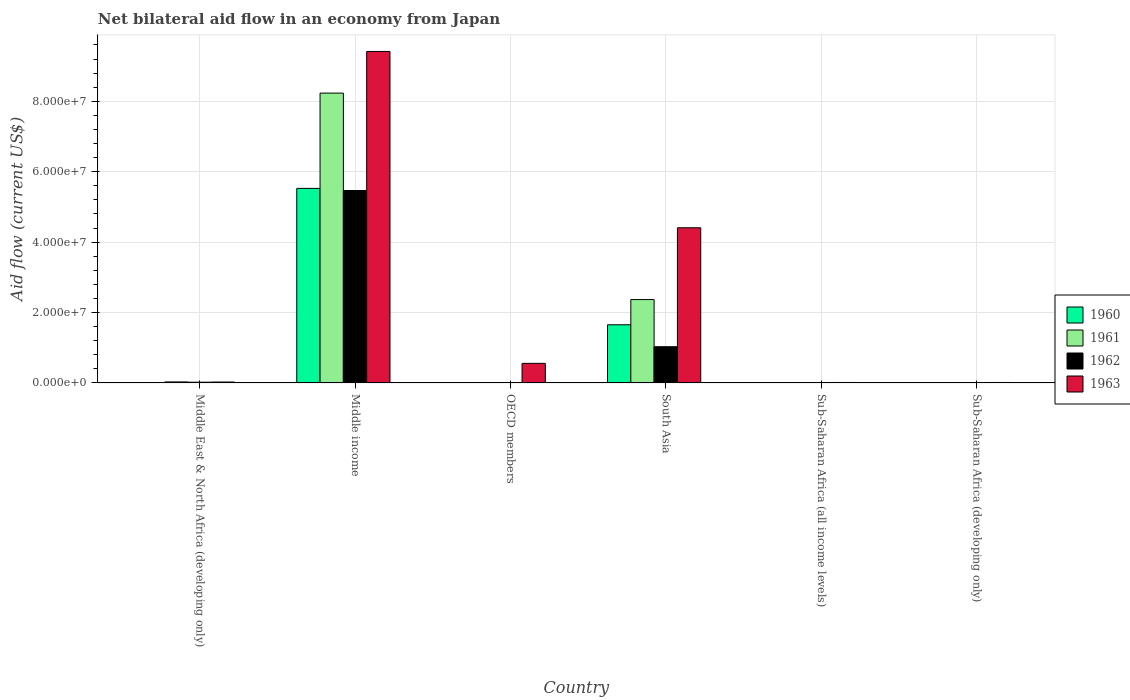How many different coloured bars are there?
Offer a terse response. 4. How many groups of bars are there?
Make the answer very short. 6. How many bars are there on the 5th tick from the left?
Provide a short and direct response. 4. How many bars are there on the 4th tick from the right?
Provide a succinct answer. 4. What is the label of the 1st group of bars from the left?
Provide a short and direct response. Middle East & North Africa (developing only). In how many cases, is the number of bars for a given country not equal to the number of legend labels?
Provide a succinct answer. 0. What is the net bilateral aid flow in 1960 in Middle East & North Africa (developing only)?
Provide a succinct answer. 9.00e+04. Across all countries, what is the maximum net bilateral aid flow in 1960?
Make the answer very short. 5.53e+07. Across all countries, what is the minimum net bilateral aid flow in 1961?
Your response must be concise. 3.00e+04. In which country was the net bilateral aid flow in 1963 maximum?
Provide a succinct answer. Middle income. In which country was the net bilateral aid flow in 1960 minimum?
Offer a very short reply. Sub-Saharan Africa (all income levels). What is the total net bilateral aid flow in 1962 in the graph?
Your response must be concise. 6.55e+07. What is the difference between the net bilateral aid flow in 1960 in Middle East & North Africa (developing only) and that in South Asia?
Ensure brevity in your answer.  -1.64e+07. What is the difference between the net bilateral aid flow in 1963 in South Asia and the net bilateral aid flow in 1960 in OECD members?
Offer a very short reply. 4.40e+07. What is the average net bilateral aid flow in 1961 per country?
Provide a short and direct response. 1.77e+07. In how many countries, is the net bilateral aid flow in 1963 greater than 64000000 US$?
Make the answer very short. 1. What is the ratio of the net bilateral aid flow in 1963 in OECD members to that in South Asia?
Keep it short and to the point. 0.13. Is the net bilateral aid flow in 1961 in Middle East & North Africa (developing only) less than that in OECD members?
Offer a very short reply. No. What is the difference between the highest and the second highest net bilateral aid flow in 1963?
Provide a succinct answer. 5.01e+07. What is the difference between the highest and the lowest net bilateral aid flow in 1960?
Ensure brevity in your answer.  5.52e+07. Is the sum of the net bilateral aid flow in 1961 in Middle income and Sub-Saharan Africa (developing only) greater than the maximum net bilateral aid flow in 1962 across all countries?
Provide a succinct answer. Yes. Is it the case that in every country, the sum of the net bilateral aid flow in 1960 and net bilateral aid flow in 1962 is greater than the sum of net bilateral aid flow in 1963 and net bilateral aid flow in 1961?
Provide a succinct answer. No. Is it the case that in every country, the sum of the net bilateral aid flow in 1961 and net bilateral aid flow in 1963 is greater than the net bilateral aid flow in 1962?
Your answer should be compact. Yes. Are all the bars in the graph horizontal?
Make the answer very short. No. How many countries are there in the graph?
Give a very brief answer. 6. Are the values on the major ticks of Y-axis written in scientific E-notation?
Your response must be concise. Yes. Where does the legend appear in the graph?
Your answer should be compact. Center right. How many legend labels are there?
Your answer should be very brief. 4. What is the title of the graph?
Provide a short and direct response. Net bilateral aid flow in an economy from Japan. What is the Aid flow (current US$) of 1960 in Middle East & North Africa (developing only)?
Your answer should be compact. 9.00e+04. What is the Aid flow (current US$) of 1961 in Middle East & North Africa (developing only)?
Make the answer very short. 2.90e+05. What is the Aid flow (current US$) in 1962 in Middle East & North Africa (developing only)?
Offer a terse response. 2.10e+05. What is the Aid flow (current US$) of 1960 in Middle income?
Provide a short and direct response. 5.53e+07. What is the Aid flow (current US$) in 1961 in Middle income?
Offer a very short reply. 8.23e+07. What is the Aid flow (current US$) of 1962 in Middle income?
Give a very brief answer. 5.47e+07. What is the Aid flow (current US$) in 1963 in Middle income?
Offer a very short reply. 9.42e+07. What is the Aid flow (current US$) in 1960 in OECD members?
Your answer should be very brief. 3.00e+04. What is the Aid flow (current US$) in 1961 in OECD members?
Offer a terse response. 5.00e+04. What is the Aid flow (current US$) in 1963 in OECD members?
Provide a short and direct response. 5.56e+06. What is the Aid flow (current US$) of 1960 in South Asia?
Make the answer very short. 1.65e+07. What is the Aid flow (current US$) in 1961 in South Asia?
Provide a short and direct response. 2.37e+07. What is the Aid flow (current US$) of 1962 in South Asia?
Keep it short and to the point. 1.03e+07. What is the Aid flow (current US$) in 1963 in South Asia?
Provide a succinct answer. 4.41e+07. What is the Aid flow (current US$) in 1961 in Sub-Saharan Africa (all income levels)?
Offer a terse response. 3.00e+04. What is the Aid flow (current US$) in 1962 in Sub-Saharan Africa (all income levels)?
Keep it short and to the point. 1.10e+05. What is the Aid flow (current US$) of 1963 in Sub-Saharan Africa (all income levels)?
Your answer should be compact. 1.30e+05. Across all countries, what is the maximum Aid flow (current US$) of 1960?
Give a very brief answer. 5.53e+07. Across all countries, what is the maximum Aid flow (current US$) in 1961?
Make the answer very short. 8.23e+07. Across all countries, what is the maximum Aid flow (current US$) in 1962?
Give a very brief answer. 5.47e+07. Across all countries, what is the maximum Aid flow (current US$) of 1963?
Offer a very short reply. 9.42e+07. Across all countries, what is the minimum Aid flow (current US$) in 1962?
Make the answer very short. 9.00e+04. Across all countries, what is the minimum Aid flow (current US$) of 1963?
Offer a very short reply. 1.30e+05. What is the total Aid flow (current US$) in 1960 in the graph?
Keep it short and to the point. 7.19e+07. What is the total Aid flow (current US$) of 1961 in the graph?
Ensure brevity in your answer.  1.06e+08. What is the total Aid flow (current US$) of 1962 in the graph?
Ensure brevity in your answer.  6.55e+07. What is the total Aid flow (current US$) of 1963 in the graph?
Ensure brevity in your answer.  1.44e+08. What is the difference between the Aid flow (current US$) in 1960 in Middle East & North Africa (developing only) and that in Middle income?
Give a very brief answer. -5.52e+07. What is the difference between the Aid flow (current US$) in 1961 in Middle East & North Africa (developing only) and that in Middle income?
Keep it short and to the point. -8.20e+07. What is the difference between the Aid flow (current US$) in 1962 in Middle East & North Africa (developing only) and that in Middle income?
Give a very brief answer. -5.44e+07. What is the difference between the Aid flow (current US$) in 1963 in Middle East & North Africa (developing only) and that in Middle income?
Offer a terse response. -9.39e+07. What is the difference between the Aid flow (current US$) of 1962 in Middle East & North Africa (developing only) and that in OECD members?
Keep it short and to the point. 1.20e+05. What is the difference between the Aid flow (current US$) of 1963 in Middle East & North Africa (developing only) and that in OECD members?
Provide a short and direct response. -5.30e+06. What is the difference between the Aid flow (current US$) of 1960 in Middle East & North Africa (developing only) and that in South Asia?
Your answer should be very brief. -1.64e+07. What is the difference between the Aid flow (current US$) of 1961 in Middle East & North Africa (developing only) and that in South Asia?
Your answer should be very brief. -2.34e+07. What is the difference between the Aid flow (current US$) in 1962 in Middle East & North Africa (developing only) and that in South Asia?
Make the answer very short. -1.01e+07. What is the difference between the Aid flow (current US$) of 1963 in Middle East & North Africa (developing only) and that in South Asia?
Keep it short and to the point. -4.38e+07. What is the difference between the Aid flow (current US$) of 1960 in Middle income and that in OECD members?
Give a very brief answer. 5.52e+07. What is the difference between the Aid flow (current US$) in 1961 in Middle income and that in OECD members?
Provide a succinct answer. 8.23e+07. What is the difference between the Aid flow (current US$) of 1962 in Middle income and that in OECD members?
Ensure brevity in your answer.  5.46e+07. What is the difference between the Aid flow (current US$) of 1963 in Middle income and that in OECD members?
Your answer should be compact. 8.86e+07. What is the difference between the Aid flow (current US$) of 1960 in Middle income and that in South Asia?
Offer a very short reply. 3.87e+07. What is the difference between the Aid flow (current US$) of 1961 in Middle income and that in South Asia?
Provide a short and direct response. 5.86e+07. What is the difference between the Aid flow (current US$) in 1962 in Middle income and that in South Asia?
Your answer should be very brief. 4.44e+07. What is the difference between the Aid flow (current US$) of 1963 in Middle income and that in South Asia?
Offer a very short reply. 5.01e+07. What is the difference between the Aid flow (current US$) of 1960 in Middle income and that in Sub-Saharan Africa (all income levels)?
Offer a terse response. 5.52e+07. What is the difference between the Aid flow (current US$) in 1961 in Middle income and that in Sub-Saharan Africa (all income levels)?
Keep it short and to the point. 8.23e+07. What is the difference between the Aid flow (current US$) in 1962 in Middle income and that in Sub-Saharan Africa (all income levels)?
Provide a succinct answer. 5.46e+07. What is the difference between the Aid flow (current US$) of 1963 in Middle income and that in Sub-Saharan Africa (all income levels)?
Offer a terse response. 9.40e+07. What is the difference between the Aid flow (current US$) of 1960 in Middle income and that in Sub-Saharan Africa (developing only)?
Give a very brief answer. 5.52e+07. What is the difference between the Aid flow (current US$) in 1961 in Middle income and that in Sub-Saharan Africa (developing only)?
Your answer should be compact. 8.23e+07. What is the difference between the Aid flow (current US$) of 1962 in Middle income and that in Sub-Saharan Africa (developing only)?
Offer a terse response. 5.46e+07. What is the difference between the Aid flow (current US$) in 1963 in Middle income and that in Sub-Saharan Africa (developing only)?
Give a very brief answer. 9.40e+07. What is the difference between the Aid flow (current US$) in 1960 in OECD members and that in South Asia?
Your answer should be compact. -1.65e+07. What is the difference between the Aid flow (current US$) in 1961 in OECD members and that in South Asia?
Your response must be concise. -2.36e+07. What is the difference between the Aid flow (current US$) in 1962 in OECD members and that in South Asia?
Your response must be concise. -1.02e+07. What is the difference between the Aid flow (current US$) in 1963 in OECD members and that in South Asia?
Offer a terse response. -3.85e+07. What is the difference between the Aid flow (current US$) in 1960 in OECD members and that in Sub-Saharan Africa (all income levels)?
Make the answer very short. 10000. What is the difference between the Aid flow (current US$) of 1961 in OECD members and that in Sub-Saharan Africa (all income levels)?
Your answer should be compact. 2.00e+04. What is the difference between the Aid flow (current US$) in 1962 in OECD members and that in Sub-Saharan Africa (all income levels)?
Provide a succinct answer. -2.00e+04. What is the difference between the Aid flow (current US$) in 1963 in OECD members and that in Sub-Saharan Africa (all income levels)?
Provide a succinct answer. 5.43e+06. What is the difference between the Aid flow (current US$) in 1962 in OECD members and that in Sub-Saharan Africa (developing only)?
Make the answer very short. -2.00e+04. What is the difference between the Aid flow (current US$) of 1963 in OECD members and that in Sub-Saharan Africa (developing only)?
Make the answer very short. 5.43e+06. What is the difference between the Aid flow (current US$) of 1960 in South Asia and that in Sub-Saharan Africa (all income levels)?
Provide a short and direct response. 1.65e+07. What is the difference between the Aid flow (current US$) of 1961 in South Asia and that in Sub-Saharan Africa (all income levels)?
Give a very brief answer. 2.36e+07. What is the difference between the Aid flow (current US$) in 1962 in South Asia and that in Sub-Saharan Africa (all income levels)?
Keep it short and to the point. 1.02e+07. What is the difference between the Aid flow (current US$) of 1963 in South Asia and that in Sub-Saharan Africa (all income levels)?
Provide a succinct answer. 4.39e+07. What is the difference between the Aid flow (current US$) in 1960 in South Asia and that in Sub-Saharan Africa (developing only)?
Offer a terse response. 1.65e+07. What is the difference between the Aid flow (current US$) in 1961 in South Asia and that in Sub-Saharan Africa (developing only)?
Give a very brief answer. 2.36e+07. What is the difference between the Aid flow (current US$) of 1962 in South Asia and that in Sub-Saharan Africa (developing only)?
Offer a very short reply. 1.02e+07. What is the difference between the Aid flow (current US$) of 1963 in South Asia and that in Sub-Saharan Africa (developing only)?
Your answer should be compact. 4.39e+07. What is the difference between the Aid flow (current US$) of 1961 in Sub-Saharan Africa (all income levels) and that in Sub-Saharan Africa (developing only)?
Your answer should be compact. 0. What is the difference between the Aid flow (current US$) of 1963 in Sub-Saharan Africa (all income levels) and that in Sub-Saharan Africa (developing only)?
Provide a succinct answer. 0. What is the difference between the Aid flow (current US$) in 1960 in Middle East & North Africa (developing only) and the Aid flow (current US$) in 1961 in Middle income?
Make the answer very short. -8.22e+07. What is the difference between the Aid flow (current US$) in 1960 in Middle East & North Africa (developing only) and the Aid flow (current US$) in 1962 in Middle income?
Offer a very short reply. -5.46e+07. What is the difference between the Aid flow (current US$) of 1960 in Middle East & North Africa (developing only) and the Aid flow (current US$) of 1963 in Middle income?
Offer a terse response. -9.41e+07. What is the difference between the Aid flow (current US$) in 1961 in Middle East & North Africa (developing only) and the Aid flow (current US$) in 1962 in Middle income?
Keep it short and to the point. -5.44e+07. What is the difference between the Aid flow (current US$) in 1961 in Middle East & North Africa (developing only) and the Aid flow (current US$) in 1963 in Middle income?
Offer a terse response. -9.39e+07. What is the difference between the Aid flow (current US$) in 1962 in Middle East & North Africa (developing only) and the Aid flow (current US$) in 1963 in Middle income?
Provide a short and direct response. -9.39e+07. What is the difference between the Aid flow (current US$) of 1960 in Middle East & North Africa (developing only) and the Aid flow (current US$) of 1962 in OECD members?
Offer a terse response. 0. What is the difference between the Aid flow (current US$) of 1960 in Middle East & North Africa (developing only) and the Aid flow (current US$) of 1963 in OECD members?
Make the answer very short. -5.47e+06. What is the difference between the Aid flow (current US$) of 1961 in Middle East & North Africa (developing only) and the Aid flow (current US$) of 1963 in OECD members?
Provide a short and direct response. -5.27e+06. What is the difference between the Aid flow (current US$) of 1962 in Middle East & North Africa (developing only) and the Aid flow (current US$) of 1963 in OECD members?
Give a very brief answer. -5.35e+06. What is the difference between the Aid flow (current US$) of 1960 in Middle East & North Africa (developing only) and the Aid flow (current US$) of 1961 in South Asia?
Your response must be concise. -2.36e+07. What is the difference between the Aid flow (current US$) of 1960 in Middle East & North Africa (developing only) and the Aid flow (current US$) of 1962 in South Asia?
Offer a very short reply. -1.02e+07. What is the difference between the Aid flow (current US$) in 1960 in Middle East & North Africa (developing only) and the Aid flow (current US$) in 1963 in South Asia?
Offer a very short reply. -4.40e+07. What is the difference between the Aid flow (current US$) of 1961 in Middle East & North Africa (developing only) and the Aid flow (current US$) of 1962 in South Asia?
Provide a succinct answer. -1.00e+07. What is the difference between the Aid flow (current US$) of 1961 in Middle East & North Africa (developing only) and the Aid flow (current US$) of 1963 in South Asia?
Make the answer very short. -4.38e+07. What is the difference between the Aid flow (current US$) in 1962 in Middle East & North Africa (developing only) and the Aid flow (current US$) in 1963 in South Asia?
Ensure brevity in your answer.  -4.39e+07. What is the difference between the Aid flow (current US$) of 1960 in Middle East & North Africa (developing only) and the Aid flow (current US$) of 1961 in Sub-Saharan Africa (all income levels)?
Offer a very short reply. 6.00e+04. What is the difference between the Aid flow (current US$) in 1960 in Middle East & North Africa (developing only) and the Aid flow (current US$) in 1962 in Sub-Saharan Africa (all income levels)?
Offer a very short reply. -2.00e+04. What is the difference between the Aid flow (current US$) in 1960 in Middle East & North Africa (developing only) and the Aid flow (current US$) in 1963 in Sub-Saharan Africa (all income levels)?
Your answer should be compact. -4.00e+04. What is the difference between the Aid flow (current US$) of 1960 in Middle East & North Africa (developing only) and the Aid flow (current US$) of 1961 in Sub-Saharan Africa (developing only)?
Provide a short and direct response. 6.00e+04. What is the difference between the Aid flow (current US$) in 1960 in Middle East & North Africa (developing only) and the Aid flow (current US$) in 1962 in Sub-Saharan Africa (developing only)?
Provide a succinct answer. -2.00e+04. What is the difference between the Aid flow (current US$) in 1960 in Middle income and the Aid flow (current US$) in 1961 in OECD members?
Give a very brief answer. 5.52e+07. What is the difference between the Aid flow (current US$) of 1960 in Middle income and the Aid flow (current US$) of 1962 in OECD members?
Offer a very short reply. 5.52e+07. What is the difference between the Aid flow (current US$) in 1960 in Middle income and the Aid flow (current US$) in 1963 in OECD members?
Your answer should be very brief. 4.97e+07. What is the difference between the Aid flow (current US$) of 1961 in Middle income and the Aid flow (current US$) of 1962 in OECD members?
Make the answer very short. 8.22e+07. What is the difference between the Aid flow (current US$) in 1961 in Middle income and the Aid flow (current US$) in 1963 in OECD members?
Make the answer very short. 7.68e+07. What is the difference between the Aid flow (current US$) in 1962 in Middle income and the Aid flow (current US$) in 1963 in OECD members?
Your response must be concise. 4.91e+07. What is the difference between the Aid flow (current US$) of 1960 in Middle income and the Aid flow (current US$) of 1961 in South Asia?
Your answer should be compact. 3.16e+07. What is the difference between the Aid flow (current US$) in 1960 in Middle income and the Aid flow (current US$) in 1962 in South Asia?
Provide a short and direct response. 4.50e+07. What is the difference between the Aid flow (current US$) in 1960 in Middle income and the Aid flow (current US$) in 1963 in South Asia?
Provide a succinct answer. 1.12e+07. What is the difference between the Aid flow (current US$) of 1961 in Middle income and the Aid flow (current US$) of 1962 in South Asia?
Make the answer very short. 7.20e+07. What is the difference between the Aid flow (current US$) in 1961 in Middle income and the Aid flow (current US$) in 1963 in South Asia?
Offer a terse response. 3.82e+07. What is the difference between the Aid flow (current US$) of 1962 in Middle income and the Aid flow (current US$) of 1963 in South Asia?
Offer a very short reply. 1.06e+07. What is the difference between the Aid flow (current US$) in 1960 in Middle income and the Aid flow (current US$) in 1961 in Sub-Saharan Africa (all income levels)?
Offer a very short reply. 5.52e+07. What is the difference between the Aid flow (current US$) in 1960 in Middle income and the Aid flow (current US$) in 1962 in Sub-Saharan Africa (all income levels)?
Provide a short and direct response. 5.52e+07. What is the difference between the Aid flow (current US$) in 1960 in Middle income and the Aid flow (current US$) in 1963 in Sub-Saharan Africa (all income levels)?
Ensure brevity in your answer.  5.51e+07. What is the difference between the Aid flow (current US$) in 1961 in Middle income and the Aid flow (current US$) in 1962 in Sub-Saharan Africa (all income levels)?
Keep it short and to the point. 8.22e+07. What is the difference between the Aid flow (current US$) in 1961 in Middle income and the Aid flow (current US$) in 1963 in Sub-Saharan Africa (all income levels)?
Your answer should be very brief. 8.22e+07. What is the difference between the Aid flow (current US$) in 1962 in Middle income and the Aid flow (current US$) in 1963 in Sub-Saharan Africa (all income levels)?
Your answer should be compact. 5.45e+07. What is the difference between the Aid flow (current US$) of 1960 in Middle income and the Aid flow (current US$) of 1961 in Sub-Saharan Africa (developing only)?
Your response must be concise. 5.52e+07. What is the difference between the Aid flow (current US$) in 1960 in Middle income and the Aid flow (current US$) in 1962 in Sub-Saharan Africa (developing only)?
Ensure brevity in your answer.  5.52e+07. What is the difference between the Aid flow (current US$) of 1960 in Middle income and the Aid flow (current US$) of 1963 in Sub-Saharan Africa (developing only)?
Your answer should be very brief. 5.51e+07. What is the difference between the Aid flow (current US$) of 1961 in Middle income and the Aid flow (current US$) of 1962 in Sub-Saharan Africa (developing only)?
Provide a succinct answer. 8.22e+07. What is the difference between the Aid flow (current US$) of 1961 in Middle income and the Aid flow (current US$) of 1963 in Sub-Saharan Africa (developing only)?
Your response must be concise. 8.22e+07. What is the difference between the Aid flow (current US$) in 1962 in Middle income and the Aid flow (current US$) in 1963 in Sub-Saharan Africa (developing only)?
Ensure brevity in your answer.  5.45e+07. What is the difference between the Aid flow (current US$) of 1960 in OECD members and the Aid flow (current US$) of 1961 in South Asia?
Keep it short and to the point. -2.36e+07. What is the difference between the Aid flow (current US$) in 1960 in OECD members and the Aid flow (current US$) in 1962 in South Asia?
Your answer should be compact. -1.03e+07. What is the difference between the Aid flow (current US$) in 1960 in OECD members and the Aid flow (current US$) in 1963 in South Asia?
Make the answer very short. -4.40e+07. What is the difference between the Aid flow (current US$) in 1961 in OECD members and the Aid flow (current US$) in 1962 in South Asia?
Ensure brevity in your answer.  -1.02e+07. What is the difference between the Aid flow (current US$) of 1961 in OECD members and the Aid flow (current US$) of 1963 in South Asia?
Ensure brevity in your answer.  -4.40e+07. What is the difference between the Aid flow (current US$) in 1962 in OECD members and the Aid flow (current US$) in 1963 in South Asia?
Keep it short and to the point. -4.40e+07. What is the difference between the Aid flow (current US$) in 1960 in OECD members and the Aid flow (current US$) in 1962 in Sub-Saharan Africa (all income levels)?
Ensure brevity in your answer.  -8.00e+04. What is the difference between the Aid flow (current US$) in 1961 in OECD members and the Aid flow (current US$) in 1962 in Sub-Saharan Africa (all income levels)?
Ensure brevity in your answer.  -6.00e+04. What is the difference between the Aid flow (current US$) in 1962 in OECD members and the Aid flow (current US$) in 1963 in Sub-Saharan Africa (all income levels)?
Provide a succinct answer. -4.00e+04. What is the difference between the Aid flow (current US$) of 1960 in OECD members and the Aid flow (current US$) of 1961 in Sub-Saharan Africa (developing only)?
Ensure brevity in your answer.  0. What is the difference between the Aid flow (current US$) in 1961 in OECD members and the Aid flow (current US$) in 1963 in Sub-Saharan Africa (developing only)?
Your response must be concise. -8.00e+04. What is the difference between the Aid flow (current US$) of 1962 in OECD members and the Aid flow (current US$) of 1963 in Sub-Saharan Africa (developing only)?
Offer a terse response. -4.00e+04. What is the difference between the Aid flow (current US$) of 1960 in South Asia and the Aid flow (current US$) of 1961 in Sub-Saharan Africa (all income levels)?
Keep it short and to the point. 1.65e+07. What is the difference between the Aid flow (current US$) in 1960 in South Asia and the Aid flow (current US$) in 1962 in Sub-Saharan Africa (all income levels)?
Make the answer very short. 1.64e+07. What is the difference between the Aid flow (current US$) of 1960 in South Asia and the Aid flow (current US$) of 1963 in Sub-Saharan Africa (all income levels)?
Ensure brevity in your answer.  1.64e+07. What is the difference between the Aid flow (current US$) of 1961 in South Asia and the Aid flow (current US$) of 1962 in Sub-Saharan Africa (all income levels)?
Your answer should be compact. 2.36e+07. What is the difference between the Aid flow (current US$) of 1961 in South Asia and the Aid flow (current US$) of 1963 in Sub-Saharan Africa (all income levels)?
Provide a short and direct response. 2.36e+07. What is the difference between the Aid flow (current US$) of 1962 in South Asia and the Aid flow (current US$) of 1963 in Sub-Saharan Africa (all income levels)?
Offer a very short reply. 1.02e+07. What is the difference between the Aid flow (current US$) in 1960 in South Asia and the Aid flow (current US$) in 1961 in Sub-Saharan Africa (developing only)?
Offer a terse response. 1.65e+07. What is the difference between the Aid flow (current US$) of 1960 in South Asia and the Aid flow (current US$) of 1962 in Sub-Saharan Africa (developing only)?
Make the answer very short. 1.64e+07. What is the difference between the Aid flow (current US$) of 1960 in South Asia and the Aid flow (current US$) of 1963 in Sub-Saharan Africa (developing only)?
Offer a very short reply. 1.64e+07. What is the difference between the Aid flow (current US$) in 1961 in South Asia and the Aid flow (current US$) in 1962 in Sub-Saharan Africa (developing only)?
Your response must be concise. 2.36e+07. What is the difference between the Aid flow (current US$) in 1961 in South Asia and the Aid flow (current US$) in 1963 in Sub-Saharan Africa (developing only)?
Provide a succinct answer. 2.36e+07. What is the difference between the Aid flow (current US$) of 1962 in South Asia and the Aid flow (current US$) of 1963 in Sub-Saharan Africa (developing only)?
Your answer should be very brief. 1.02e+07. What is the difference between the Aid flow (current US$) in 1960 in Sub-Saharan Africa (all income levels) and the Aid flow (current US$) in 1962 in Sub-Saharan Africa (developing only)?
Ensure brevity in your answer.  -9.00e+04. What is the difference between the Aid flow (current US$) in 1960 in Sub-Saharan Africa (all income levels) and the Aid flow (current US$) in 1963 in Sub-Saharan Africa (developing only)?
Ensure brevity in your answer.  -1.10e+05. What is the difference between the Aid flow (current US$) of 1962 in Sub-Saharan Africa (all income levels) and the Aid flow (current US$) of 1963 in Sub-Saharan Africa (developing only)?
Your answer should be compact. -2.00e+04. What is the average Aid flow (current US$) of 1960 per country?
Ensure brevity in your answer.  1.20e+07. What is the average Aid flow (current US$) of 1961 per country?
Make the answer very short. 1.77e+07. What is the average Aid flow (current US$) in 1962 per country?
Offer a very short reply. 1.09e+07. What is the average Aid flow (current US$) of 1963 per country?
Offer a terse response. 2.40e+07. What is the difference between the Aid flow (current US$) of 1961 and Aid flow (current US$) of 1963 in Middle East & North Africa (developing only)?
Ensure brevity in your answer.  3.00e+04. What is the difference between the Aid flow (current US$) in 1960 and Aid flow (current US$) in 1961 in Middle income?
Your answer should be very brief. -2.71e+07. What is the difference between the Aid flow (current US$) in 1960 and Aid flow (current US$) in 1962 in Middle income?
Your answer should be very brief. 6.00e+05. What is the difference between the Aid flow (current US$) in 1960 and Aid flow (current US$) in 1963 in Middle income?
Offer a terse response. -3.89e+07. What is the difference between the Aid flow (current US$) in 1961 and Aid flow (current US$) in 1962 in Middle income?
Your answer should be very brief. 2.77e+07. What is the difference between the Aid flow (current US$) of 1961 and Aid flow (current US$) of 1963 in Middle income?
Make the answer very short. -1.18e+07. What is the difference between the Aid flow (current US$) in 1962 and Aid flow (current US$) in 1963 in Middle income?
Provide a short and direct response. -3.95e+07. What is the difference between the Aid flow (current US$) in 1960 and Aid flow (current US$) in 1961 in OECD members?
Provide a succinct answer. -2.00e+04. What is the difference between the Aid flow (current US$) in 1960 and Aid flow (current US$) in 1962 in OECD members?
Your answer should be compact. -6.00e+04. What is the difference between the Aid flow (current US$) in 1960 and Aid flow (current US$) in 1963 in OECD members?
Offer a terse response. -5.53e+06. What is the difference between the Aid flow (current US$) of 1961 and Aid flow (current US$) of 1963 in OECD members?
Provide a succinct answer. -5.51e+06. What is the difference between the Aid flow (current US$) in 1962 and Aid flow (current US$) in 1963 in OECD members?
Offer a very short reply. -5.47e+06. What is the difference between the Aid flow (current US$) of 1960 and Aid flow (current US$) of 1961 in South Asia?
Provide a short and direct response. -7.16e+06. What is the difference between the Aid flow (current US$) in 1960 and Aid flow (current US$) in 1962 in South Asia?
Provide a succinct answer. 6.23e+06. What is the difference between the Aid flow (current US$) of 1960 and Aid flow (current US$) of 1963 in South Asia?
Keep it short and to the point. -2.76e+07. What is the difference between the Aid flow (current US$) of 1961 and Aid flow (current US$) of 1962 in South Asia?
Offer a terse response. 1.34e+07. What is the difference between the Aid flow (current US$) of 1961 and Aid flow (current US$) of 1963 in South Asia?
Your answer should be very brief. -2.04e+07. What is the difference between the Aid flow (current US$) in 1962 and Aid flow (current US$) in 1963 in South Asia?
Your answer should be very brief. -3.38e+07. What is the difference between the Aid flow (current US$) in 1960 and Aid flow (current US$) in 1962 in Sub-Saharan Africa (all income levels)?
Your answer should be very brief. -9.00e+04. What is the difference between the Aid flow (current US$) in 1960 and Aid flow (current US$) in 1963 in Sub-Saharan Africa (all income levels)?
Offer a terse response. -1.10e+05. What is the difference between the Aid flow (current US$) in 1961 and Aid flow (current US$) in 1962 in Sub-Saharan Africa (all income levels)?
Make the answer very short. -8.00e+04. What is the difference between the Aid flow (current US$) of 1961 and Aid flow (current US$) of 1963 in Sub-Saharan Africa (all income levels)?
Your response must be concise. -1.00e+05. What is the difference between the Aid flow (current US$) in 1960 and Aid flow (current US$) in 1963 in Sub-Saharan Africa (developing only)?
Keep it short and to the point. -1.10e+05. What is the difference between the Aid flow (current US$) in 1961 and Aid flow (current US$) in 1962 in Sub-Saharan Africa (developing only)?
Provide a succinct answer. -8.00e+04. What is the difference between the Aid flow (current US$) in 1962 and Aid flow (current US$) in 1963 in Sub-Saharan Africa (developing only)?
Keep it short and to the point. -2.00e+04. What is the ratio of the Aid flow (current US$) in 1960 in Middle East & North Africa (developing only) to that in Middle income?
Give a very brief answer. 0. What is the ratio of the Aid flow (current US$) in 1961 in Middle East & North Africa (developing only) to that in Middle income?
Your answer should be compact. 0. What is the ratio of the Aid flow (current US$) of 1962 in Middle East & North Africa (developing only) to that in Middle income?
Provide a succinct answer. 0. What is the ratio of the Aid flow (current US$) of 1963 in Middle East & North Africa (developing only) to that in Middle income?
Give a very brief answer. 0. What is the ratio of the Aid flow (current US$) of 1960 in Middle East & North Africa (developing only) to that in OECD members?
Offer a very short reply. 3. What is the ratio of the Aid flow (current US$) in 1962 in Middle East & North Africa (developing only) to that in OECD members?
Ensure brevity in your answer.  2.33. What is the ratio of the Aid flow (current US$) in 1963 in Middle East & North Africa (developing only) to that in OECD members?
Your answer should be very brief. 0.05. What is the ratio of the Aid flow (current US$) of 1960 in Middle East & North Africa (developing only) to that in South Asia?
Offer a terse response. 0.01. What is the ratio of the Aid flow (current US$) in 1961 in Middle East & North Africa (developing only) to that in South Asia?
Your answer should be very brief. 0.01. What is the ratio of the Aid flow (current US$) in 1962 in Middle East & North Africa (developing only) to that in South Asia?
Make the answer very short. 0.02. What is the ratio of the Aid flow (current US$) in 1963 in Middle East & North Africa (developing only) to that in South Asia?
Give a very brief answer. 0.01. What is the ratio of the Aid flow (current US$) of 1961 in Middle East & North Africa (developing only) to that in Sub-Saharan Africa (all income levels)?
Provide a short and direct response. 9.67. What is the ratio of the Aid flow (current US$) in 1962 in Middle East & North Africa (developing only) to that in Sub-Saharan Africa (all income levels)?
Your answer should be very brief. 1.91. What is the ratio of the Aid flow (current US$) of 1961 in Middle East & North Africa (developing only) to that in Sub-Saharan Africa (developing only)?
Provide a short and direct response. 9.67. What is the ratio of the Aid flow (current US$) in 1962 in Middle East & North Africa (developing only) to that in Sub-Saharan Africa (developing only)?
Your answer should be compact. 1.91. What is the ratio of the Aid flow (current US$) of 1963 in Middle East & North Africa (developing only) to that in Sub-Saharan Africa (developing only)?
Offer a terse response. 2. What is the ratio of the Aid flow (current US$) in 1960 in Middle income to that in OECD members?
Give a very brief answer. 1842. What is the ratio of the Aid flow (current US$) in 1961 in Middle income to that in OECD members?
Provide a short and direct response. 1646.4. What is the ratio of the Aid flow (current US$) of 1962 in Middle income to that in OECD members?
Your answer should be very brief. 607.33. What is the ratio of the Aid flow (current US$) of 1963 in Middle income to that in OECD members?
Ensure brevity in your answer.  16.93. What is the ratio of the Aid flow (current US$) in 1960 in Middle income to that in South Asia?
Make the answer very short. 3.35. What is the ratio of the Aid flow (current US$) of 1961 in Middle income to that in South Asia?
Provide a succinct answer. 3.48. What is the ratio of the Aid flow (current US$) in 1962 in Middle income to that in South Asia?
Make the answer very short. 5.31. What is the ratio of the Aid flow (current US$) in 1963 in Middle income to that in South Asia?
Make the answer very short. 2.14. What is the ratio of the Aid flow (current US$) of 1960 in Middle income to that in Sub-Saharan Africa (all income levels)?
Provide a succinct answer. 2763. What is the ratio of the Aid flow (current US$) of 1961 in Middle income to that in Sub-Saharan Africa (all income levels)?
Give a very brief answer. 2744. What is the ratio of the Aid flow (current US$) of 1962 in Middle income to that in Sub-Saharan Africa (all income levels)?
Your answer should be very brief. 496.91. What is the ratio of the Aid flow (current US$) in 1963 in Middle income to that in Sub-Saharan Africa (all income levels)?
Give a very brief answer. 724.23. What is the ratio of the Aid flow (current US$) of 1960 in Middle income to that in Sub-Saharan Africa (developing only)?
Ensure brevity in your answer.  2763. What is the ratio of the Aid flow (current US$) in 1961 in Middle income to that in Sub-Saharan Africa (developing only)?
Offer a very short reply. 2744. What is the ratio of the Aid flow (current US$) of 1962 in Middle income to that in Sub-Saharan Africa (developing only)?
Provide a short and direct response. 496.91. What is the ratio of the Aid flow (current US$) of 1963 in Middle income to that in Sub-Saharan Africa (developing only)?
Your answer should be compact. 724.23. What is the ratio of the Aid flow (current US$) in 1960 in OECD members to that in South Asia?
Your response must be concise. 0. What is the ratio of the Aid flow (current US$) of 1961 in OECD members to that in South Asia?
Offer a terse response. 0. What is the ratio of the Aid flow (current US$) in 1962 in OECD members to that in South Asia?
Ensure brevity in your answer.  0.01. What is the ratio of the Aid flow (current US$) in 1963 in OECD members to that in South Asia?
Keep it short and to the point. 0.13. What is the ratio of the Aid flow (current US$) of 1960 in OECD members to that in Sub-Saharan Africa (all income levels)?
Ensure brevity in your answer.  1.5. What is the ratio of the Aid flow (current US$) in 1961 in OECD members to that in Sub-Saharan Africa (all income levels)?
Ensure brevity in your answer.  1.67. What is the ratio of the Aid flow (current US$) in 1962 in OECD members to that in Sub-Saharan Africa (all income levels)?
Your response must be concise. 0.82. What is the ratio of the Aid flow (current US$) in 1963 in OECD members to that in Sub-Saharan Africa (all income levels)?
Provide a succinct answer. 42.77. What is the ratio of the Aid flow (current US$) of 1962 in OECD members to that in Sub-Saharan Africa (developing only)?
Your answer should be compact. 0.82. What is the ratio of the Aid flow (current US$) in 1963 in OECD members to that in Sub-Saharan Africa (developing only)?
Offer a terse response. 42.77. What is the ratio of the Aid flow (current US$) of 1960 in South Asia to that in Sub-Saharan Africa (all income levels)?
Offer a very short reply. 826. What is the ratio of the Aid flow (current US$) in 1961 in South Asia to that in Sub-Saharan Africa (all income levels)?
Make the answer very short. 789.33. What is the ratio of the Aid flow (current US$) of 1962 in South Asia to that in Sub-Saharan Africa (all income levels)?
Your answer should be compact. 93.55. What is the ratio of the Aid flow (current US$) in 1963 in South Asia to that in Sub-Saharan Africa (all income levels)?
Ensure brevity in your answer.  339. What is the ratio of the Aid flow (current US$) in 1960 in South Asia to that in Sub-Saharan Africa (developing only)?
Give a very brief answer. 826. What is the ratio of the Aid flow (current US$) of 1961 in South Asia to that in Sub-Saharan Africa (developing only)?
Offer a terse response. 789.33. What is the ratio of the Aid flow (current US$) in 1962 in South Asia to that in Sub-Saharan Africa (developing only)?
Your response must be concise. 93.55. What is the ratio of the Aid flow (current US$) of 1963 in South Asia to that in Sub-Saharan Africa (developing only)?
Your answer should be very brief. 339. What is the ratio of the Aid flow (current US$) of 1961 in Sub-Saharan Africa (all income levels) to that in Sub-Saharan Africa (developing only)?
Keep it short and to the point. 1. What is the ratio of the Aid flow (current US$) of 1962 in Sub-Saharan Africa (all income levels) to that in Sub-Saharan Africa (developing only)?
Provide a succinct answer. 1. What is the difference between the highest and the second highest Aid flow (current US$) of 1960?
Provide a succinct answer. 3.87e+07. What is the difference between the highest and the second highest Aid flow (current US$) of 1961?
Make the answer very short. 5.86e+07. What is the difference between the highest and the second highest Aid flow (current US$) in 1962?
Your response must be concise. 4.44e+07. What is the difference between the highest and the second highest Aid flow (current US$) in 1963?
Your answer should be very brief. 5.01e+07. What is the difference between the highest and the lowest Aid flow (current US$) in 1960?
Your answer should be compact. 5.52e+07. What is the difference between the highest and the lowest Aid flow (current US$) of 1961?
Offer a very short reply. 8.23e+07. What is the difference between the highest and the lowest Aid flow (current US$) in 1962?
Provide a succinct answer. 5.46e+07. What is the difference between the highest and the lowest Aid flow (current US$) in 1963?
Keep it short and to the point. 9.40e+07. 